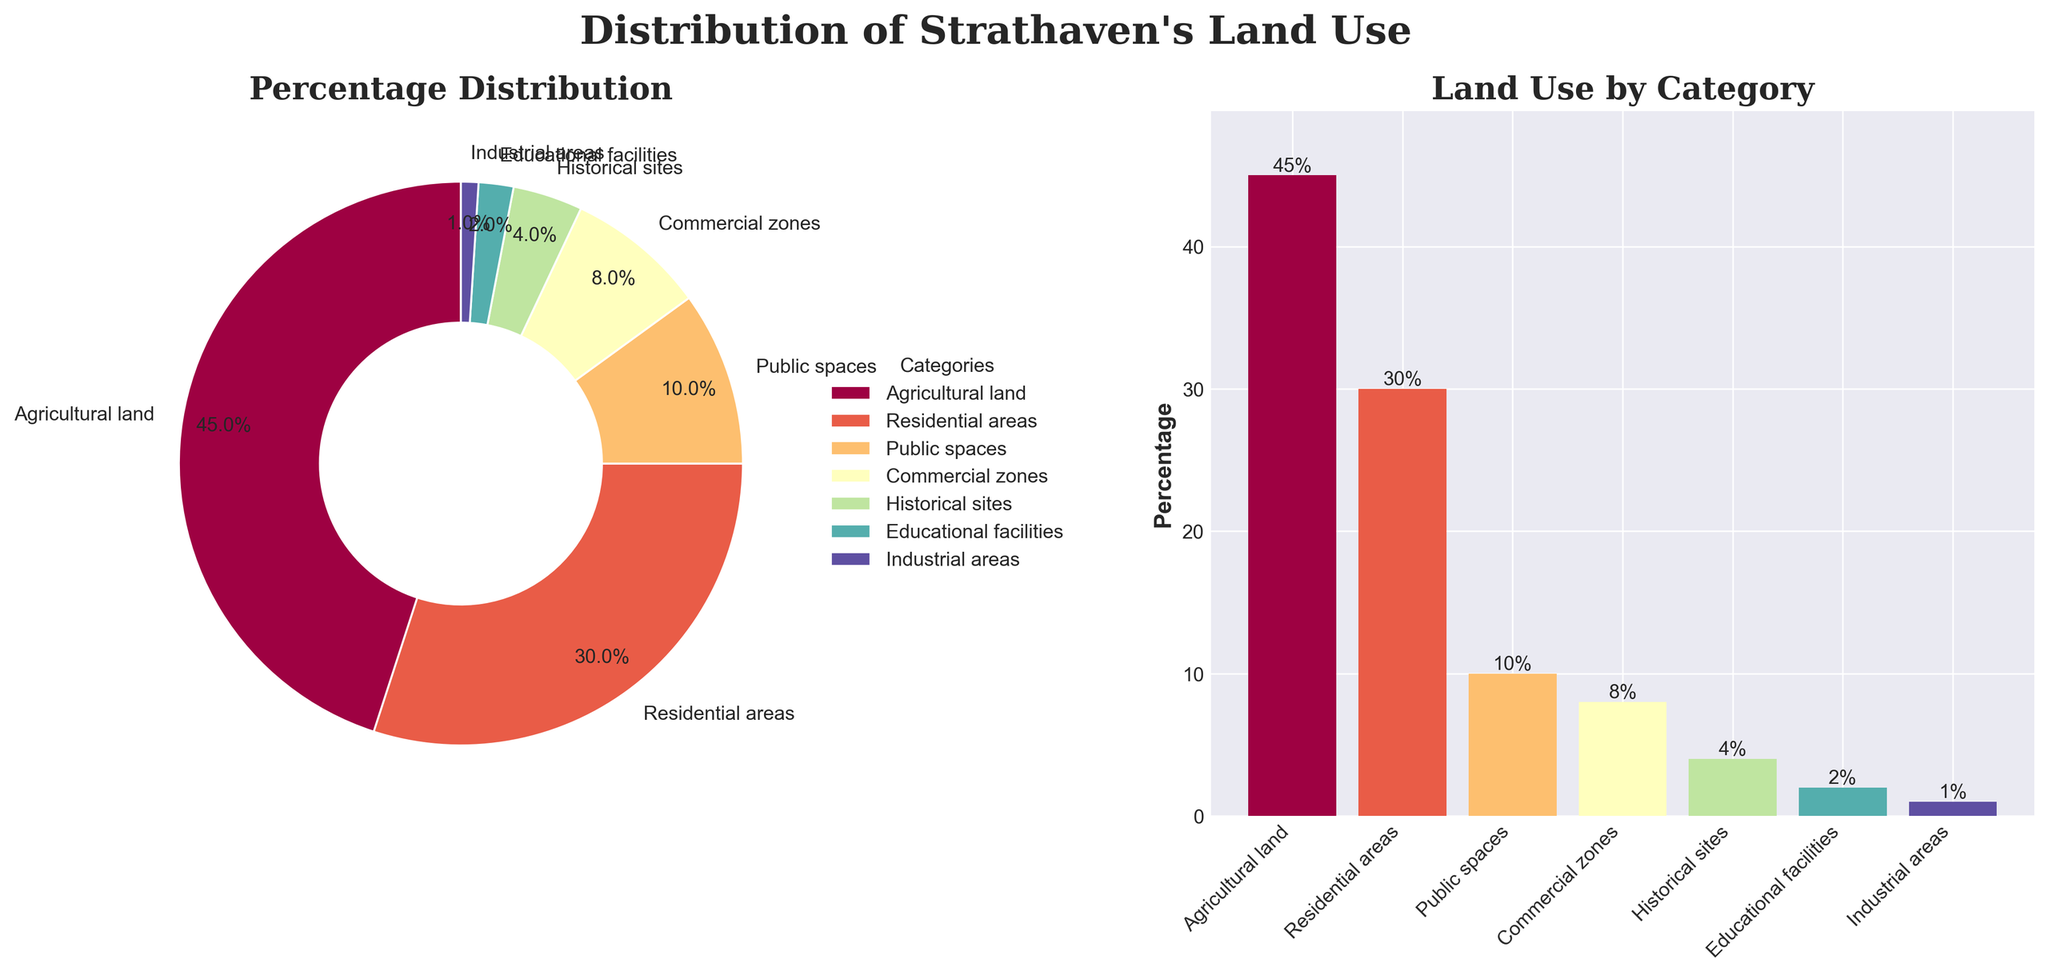What percentage of land in Strathaven is dedicated to agricultural use? The pie chart and bar chart both indicate the percentage of land dedicated to different categories. By looking at either chart, we can see "Agricultural land" is dedicated to 45% of the land.
Answer: 45% Which category of land use takes up the smallest percentage in Strathaven? Both charts show the categories and the corresponding percentages. "Industrial areas" have the smallest percentage at 1%.
Answer: Industrial areas What is the combined percentage of land use for residential areas and public spaces? Look at the percentages for "Residential areas" (30%) and "Public spaces" (10%), then add them together. 30% + 10% = 40%
Answer: 40% How does the percentage of land dedicated to historical sites compare to that for commercial zones? The percentage for "Historical sites" is 4% and for "Commercial zones" is 8%. 4% is less than 8%.
Answer: Historical sites: 4%, Commercial zones: 8% Which category has the second highest percentage of land use in Strathaven? From viewing both charts, the highest is "Agricultural land" at 45%. The second highest is "Residential areas" at 30%.
Answer: Residential areas Sum the percentage of land dedicated to educational facilities and industrial areas. Find the percentages for "Educational facilities" (2%) and "Industrial areas" (1%), then add them together. 2% + 1% = 3%
Answer: 3% How many categories are shown in the charts for Strathaven's land use? Count the number of distinct categories listed in the pie chart and bar chart. There are 7 categories.
Answer: 7 Which category uses more land: public spaces or historical sites? Compare the percentages for "Public spaces" (10%) and "Historical sites" (4%). Public spaces use more land.
Answer: Public spaces Is the percentage of land use for residential areas greater than the combined percentage of historical sites and educational facilities? The percentage for "Residential areas" is 30%. The combined percentage for "Historical sites" (4%) and "Educational facilities" (2%) is 4% + 2% = 6%. 30% is greater than 6%.
Answer: Yes What categories account for less than 5% of land use each? Look at the percentages in either chart. "Historical sites" (4%), "Educational facilities" (2%), and "Industrial areas" (1%) account for less than 5% each.
Answer: Historical sites, Educational facilities, Industrial areas 